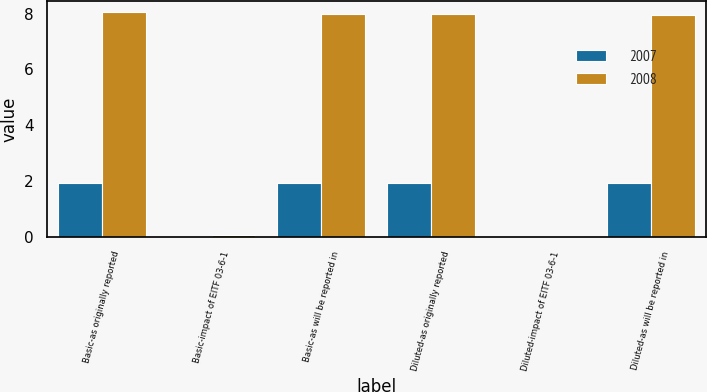Convert chart to OTSL. <chart><loc_0><loc_0><loc_500><loc_500><stacked_bar_chart><ecel><fcel>Basic-as originally reported<fcel>Basic-impact of EITF 03-6-1<fcel>Basic-as will be reported in<fcel>Diluted-as originally reported<fcel>Diluted-impact of EITF 03-6-1<fcel>Diluted-as will be reported in<nl><fcel>2007<fcel>1.95<fcel>0.01<fcel>1.94<fcel>1.95<fcel>0.01<fcel>1.94<nl><fcel>2008<fcel>8.05<fcel>0.07<fcel>7.98<fcel>8<fcel>0.04<fcel>7.96<nl></chart> 